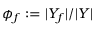<formula> <loc_0><loc_0><loc_500><loc_500>\phi _ { f } \colon = | Y _ { f } | / | Y |</formula> 